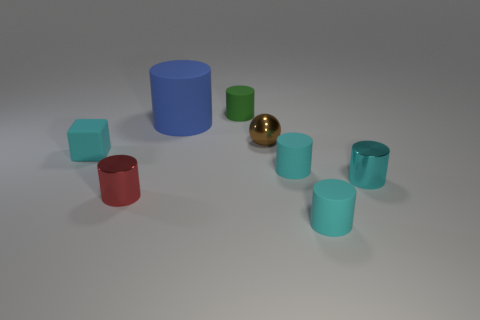Add 1 cyan matte objects. How many objects exist? 9 Subtract all tiny cylinders. How many cylinders are left? 1 Subtract all cylinders. How many objects are left? 2 Subtract all large red metallic things. Subtract all tiny red shiny cylinders. How many objects are left? 7 Add 2 cyan cylinders. How many cyan cylinders are left? 5 Add 1 tiny brown things. How many tiny brown things exist? 2 Subtract all blue cylinders. How many cylinders are left? 5 Subtract 3 cyan cylinders. How many objects are left? 5 Subtract 2 cylinders. How many cylinders are left? 4 Subtract all green cylinders. Subtract all red cubes. How many cylinders are left? 5 